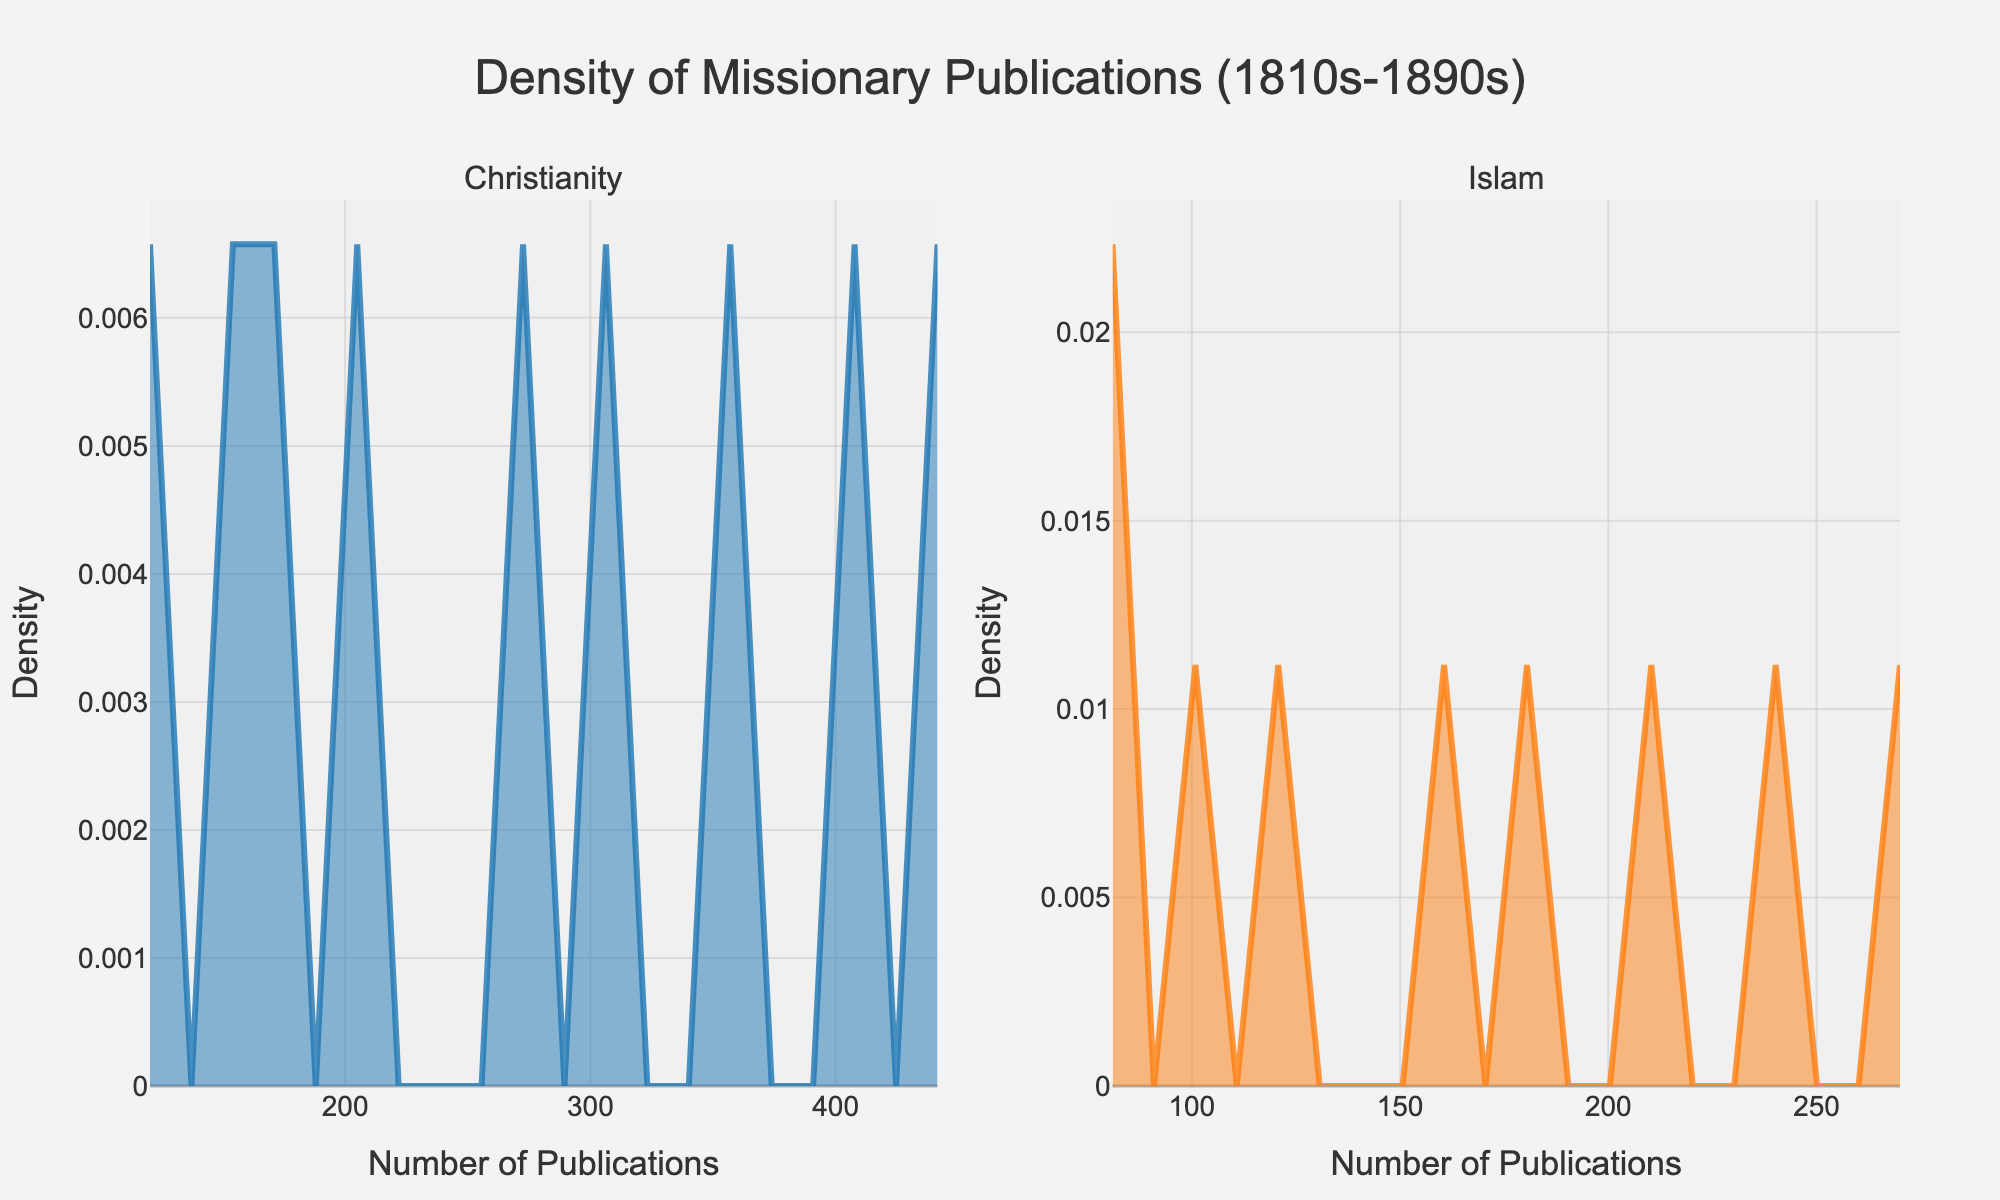Which religion has the higher peak in the density plot? The density plot shows two subplots for Christianity and Islam. The peak of the density curve for Christianity is higher than that of Islam.
Answer: Christianity What's the title of the plot? The title is displayed at the top of the figure. It reads "Density of Missionary Publications (1810s-1890s)."
Answer: Density of Missionary Publications (1810s-1890s) In which decade does the density plot for Christianity appear to have the highest number of publications? Observing the density plot, the peak for Christianity is highest around the decade range of 450 publications.
Answer: 1890s How do the publication densities compare between Christianity and Islam around the 1850s? The density of publications for Christianity in the 1850s is higher compared to Islam. The subplot for Christianity shows a noticeable peak above the 150 mark, while the peak for Islam is lower close to 85.
Answer: Christianity > Islam What are the x-axis labels for both subplots? The x-axis label for both subplots is "Number of Publications."
Answer: Number of Publications What differences can be observed in the y-axis labels between the two subplots? Both subplots have the same y-axis label which is "Density". There are no differences in the y-axis labels.
Answer: None By how much does the highest density of Christian missionary publications exceed that of Islamic missionary publications? The peak density for Christianity is around 0.013, whereas for Islam, it is about 0.009. Therefore, the difference is 0.013 - 0.009 = 0.004.
Answer: 0.004 Do the publication densities of Christianity and Islam overlap at any point? Upon examining the subplots, there are points where the densities seem to overlap slightly, especially in the lower range of publications, around the 100 to 150 mark.
Answer: Yes Which subplot shows a wider spread of data? Comparing the subplots, the Christianity subplot has density values spanning a wider range of publication numbers compared to the Islam subplot.
Answer: Christianity 